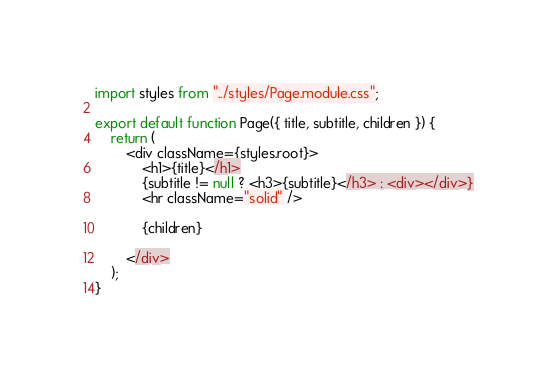Convert code to text. <code><loc_0><loc_0><loc_500><loc_500><_JavaScript_>import styles from "../styles/Page.module.css";

export default function Page({ title, subtitle, children }) {
	return (
		<div className={styles.root}>
			<h1>{title}</h1>
			{subtitle != null ? <h3>{subtitle}</h3> : <div></div>}
			<hr className="solid" />
			
			{children}
	
		</div>
	);
}
</code> 